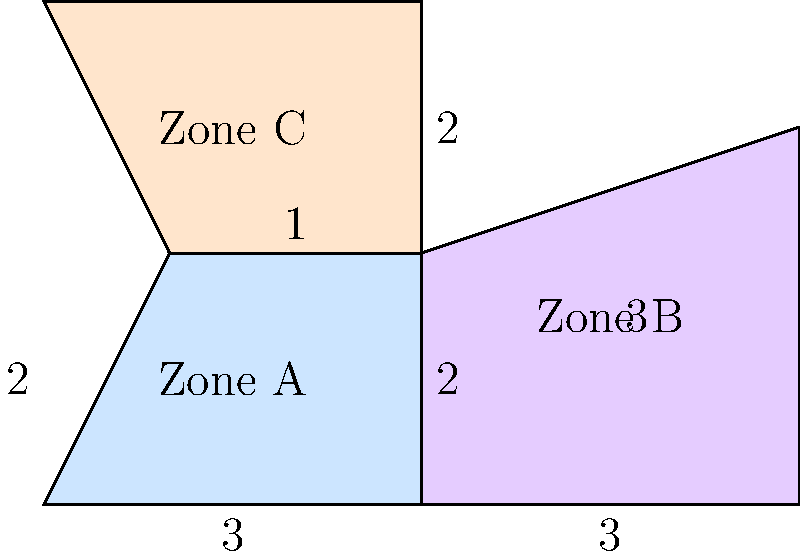An emerging market is divided into three investment zones as shown in the map above. Zone A is a rectangle with a triangular section removed, Zone B is a trapezoid, and Zone C is a rectangle. All measurements are in kilometers. What is the total area of all three zones combined? Let's calculate the area of each zone separately:

1. Zone A:
   - Area of rectangle: $3 \times 2 = 6$ km²
   - Area of triangle: $\frac{1}{2} \times 1 \times 2 = 1$ km²
   - Area of Zone A: $6 - 1 = 5$ km²

2. Zone B (trapezoid):
   - Area = $\frac{1}{2}(a+b)h$, where $a$ and $b$ are parallel sides and $h$ is height
   - $a = 3$ km, $b = 3$ km, $h = 3$ km
   - Area of Zone B: $\frac{1}{2}(3+3) \times 3 = 9$ km²

3. Zone C (rectangle):
   - Area = length $\times$ width
   - $3 \times 2 = 6$ km²

Total area:
$$ \text{Total Area} = \text{Area}_A + \text{Area}_B + \text{Area}_C $$
$$ \text{Total Area} = 5 + 9 + 6 = 20 \text{ km²} $$
Answer: 20 km² 